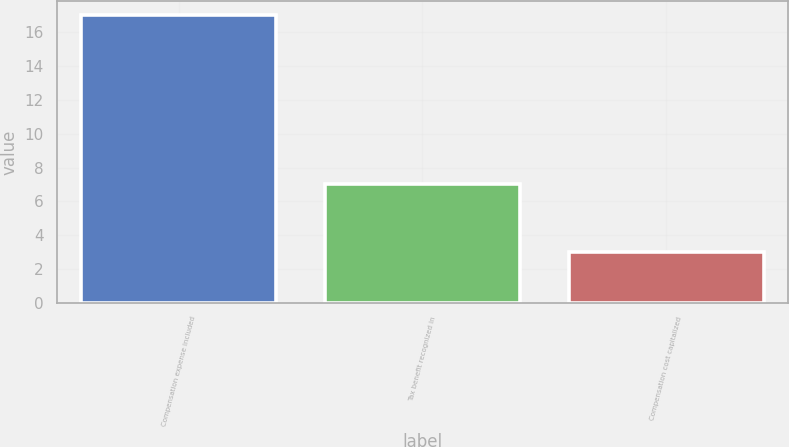Convert chart. <chart><loc_0><loc_0><loc_500><loc_500><bar_chart><fcel>Compensation expense included<fcel>Tax benefit recognized in<fcel>Compensation cost capitalized<nl><fcel>17<fcel>7<fcel>3<nl></chart> 